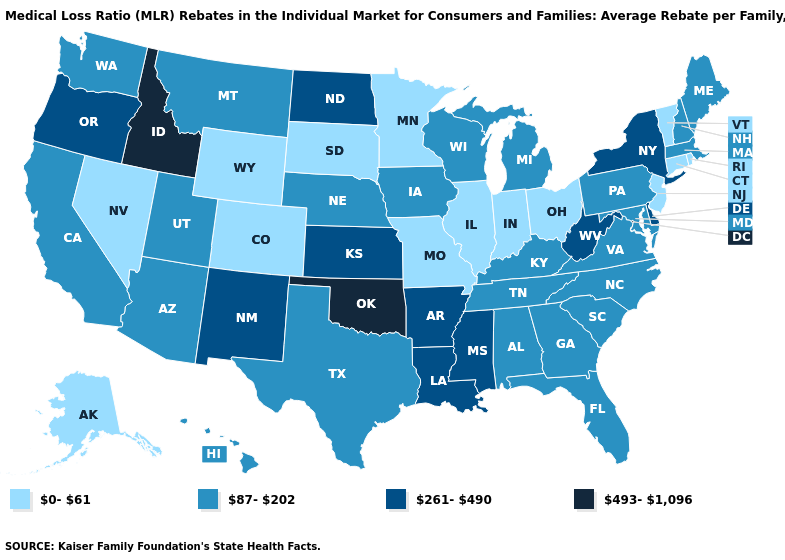Which states have the lowest value in the South?
Short answer required. Alabama, Florida, Georgia, Kentucky, Maryland, North Carolina, South Carolina, Tennessee, Texas, Virginia. What is the value of Virginia?
Answer briefly. 87-202. Does Florida have the lowest value in the South?
Write a very short answer. Yes. Which states have the lowest value in the South?
Quick response, please. Alabama, Florida, Georgia, Kentucky, Maryland, North Carolina, South Carolina, Tennessee, Texas, Virginia. Among the states that border Idaho , which have the lowest value?
Be succinct. Nevada, Wyoming. What is the value of Oklahoma?
Write a very short answer. 493-1,096. Name the states that have a value in the range 87-202?
Write a very short answer. Alabama, Arizona, California, Florida, Georgia, Hawaii, Iowa, Kentucky, Maine, Maryland, Massachusetts, Michigan, Montana, Nebraska, New Hampshire, North Carolina, Pennsylvania, South Carolina, Tennessee, Texas, Utah, Virginia, Washington, Wisconsin. How many symbols are there in the legend?
Short answer required. 4. Does the first symbol in the legend represent the smallest category?
Short answer required. Yes. What is the lowest value in the Northeast?
Give a very brief answer. 0-61. How many symbols are there in the legend?
Be succinct. 4. What is the value of Nebraska?
Write a very short answer. 87-202. Name the states that have a value in the range 87-202?
Quick response, please. Alabama, Arizona, California, Florida, Georgia, Hawaii, Iowa, Kentucky, Maine, Maryland, Massachusetts, Michigan, Montana, Nebraska, New Hampshire, North Carolina, Pennsylvania, South Carolina, Tennessee, Texas, Utah, Virginia, Washington, Wisconsin. What is the value of Massachusetts?
Give a very brief answer. 87-202. Name the states that have a value in the range 87-202?
Write a very short answer. Alabama, Arizona, California, Florida, Georgia, Hawaii, Iowa, Kentucky, Maine, Maryland, Massachusetts, Michigan, Montana, Nebraska, New Hampshire, North Carolina, Pennsylvania, South Carolina, Tennessee, Texas, Utah, Virginia, Washington, Wisconsin. 